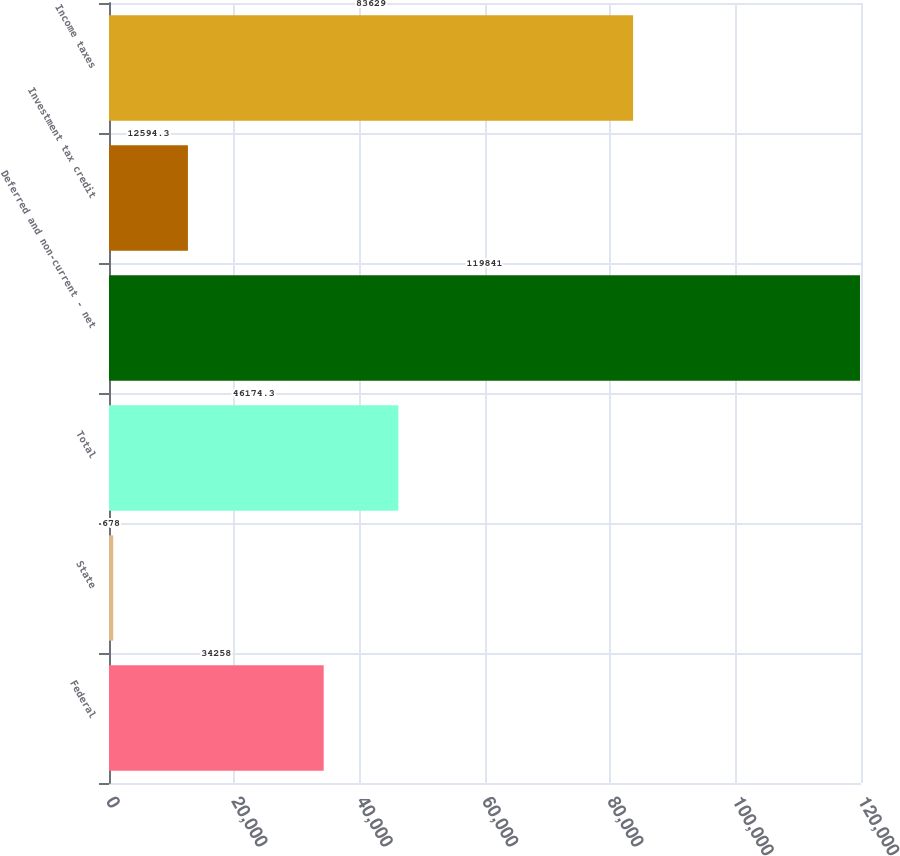Convert chart to OTSL. <chart><loc_0><loc_0><loc_500><loc_500><bar_chart><fcel>Federal<fcel>State<fcel>Total<fcel>Deferred and non-current - net<fcel>Investment tax credit<fcel>Income taxes<nl><fcel>34258<fcel>678<fcel>46174.3<fcel>119841<fcel>12594.3<fcel>83629<nl></chart> 